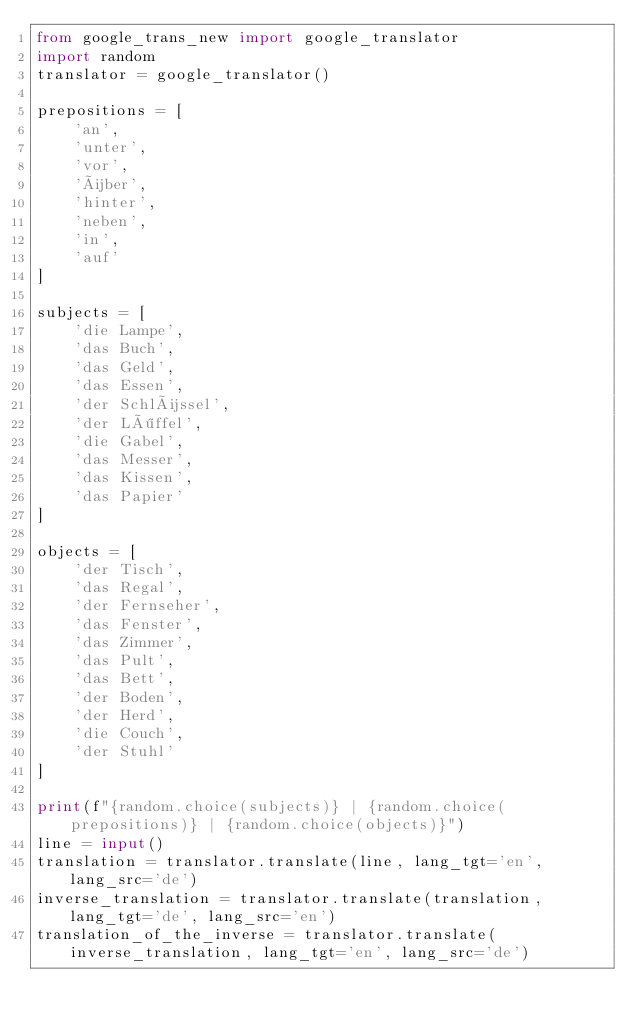<code> <loc_0><loc_0><loc_500><loc_500><_Python_>from google_trans_new import google_translator
import random
translator = google_translator()

prepositions = [
    'an',
    'unter',
    'vor',
    'über',
    'hinter',
    'neben',
    'in',
    'auf'
]

subjects = [
    'die Lampe',
    'das Buch',
    'das Geld',
    'das Essen',
    'der Schlüssel',
    'der Löffel',
    'die Gabel', 
    'das Messer',
    'das Kissen',
    'das Papier'
]

objects = [
    'der Tisch',
    'das Regal',
    'der Fernseher',
    'das Fenster',
    'das Zimmer',
    'das Pult',
    'das Bett',
    'der Boden',
    'der Herd',
    'die Couch',
    'der Stuhl'
]

print(f"{random.choice(subjects)} | {random.choice(prepositions)} | {random.choice(objects)}")
line = input()
translation = translator.translate(line, lang_tgt='en', lang_src='de')
inverse_translation = translator.translate(translation, lang_tgt='de', lang_src='en')
translation_of_the_inverse = translator.translate(inverse_translation, lang_tgt='en', lang_src='de')</code> 